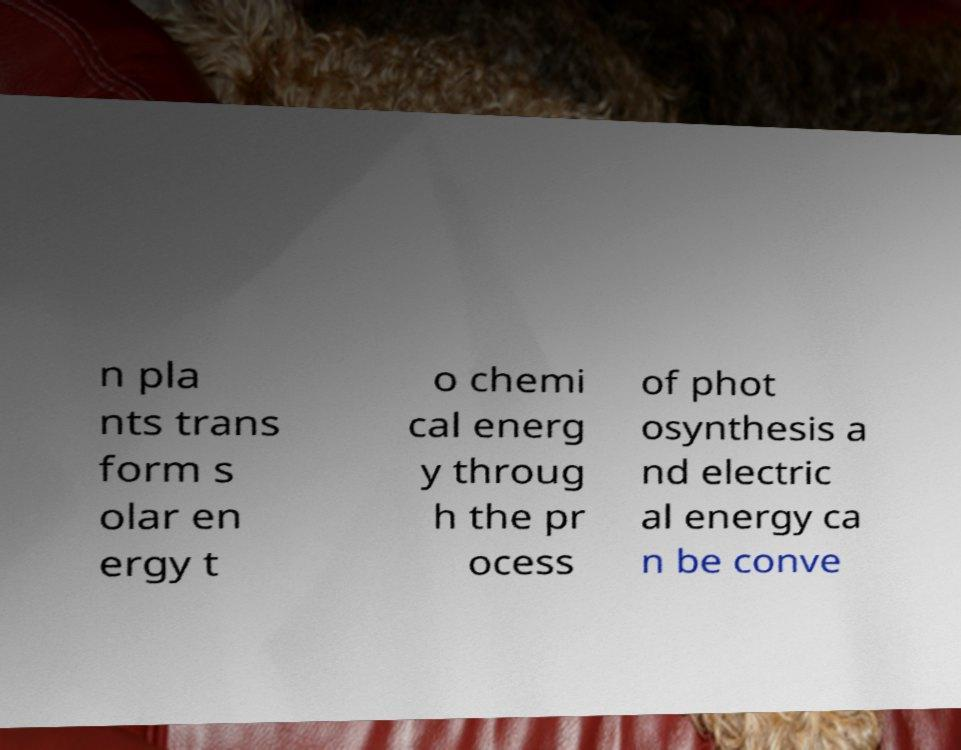I need the written content from this picture converted into text. Can you do that? n pla nts trans form s olar en ergy t o chemi cal energ y throug h the pr ocess of phot osynthesis a nd electric al energy ca n be conve 